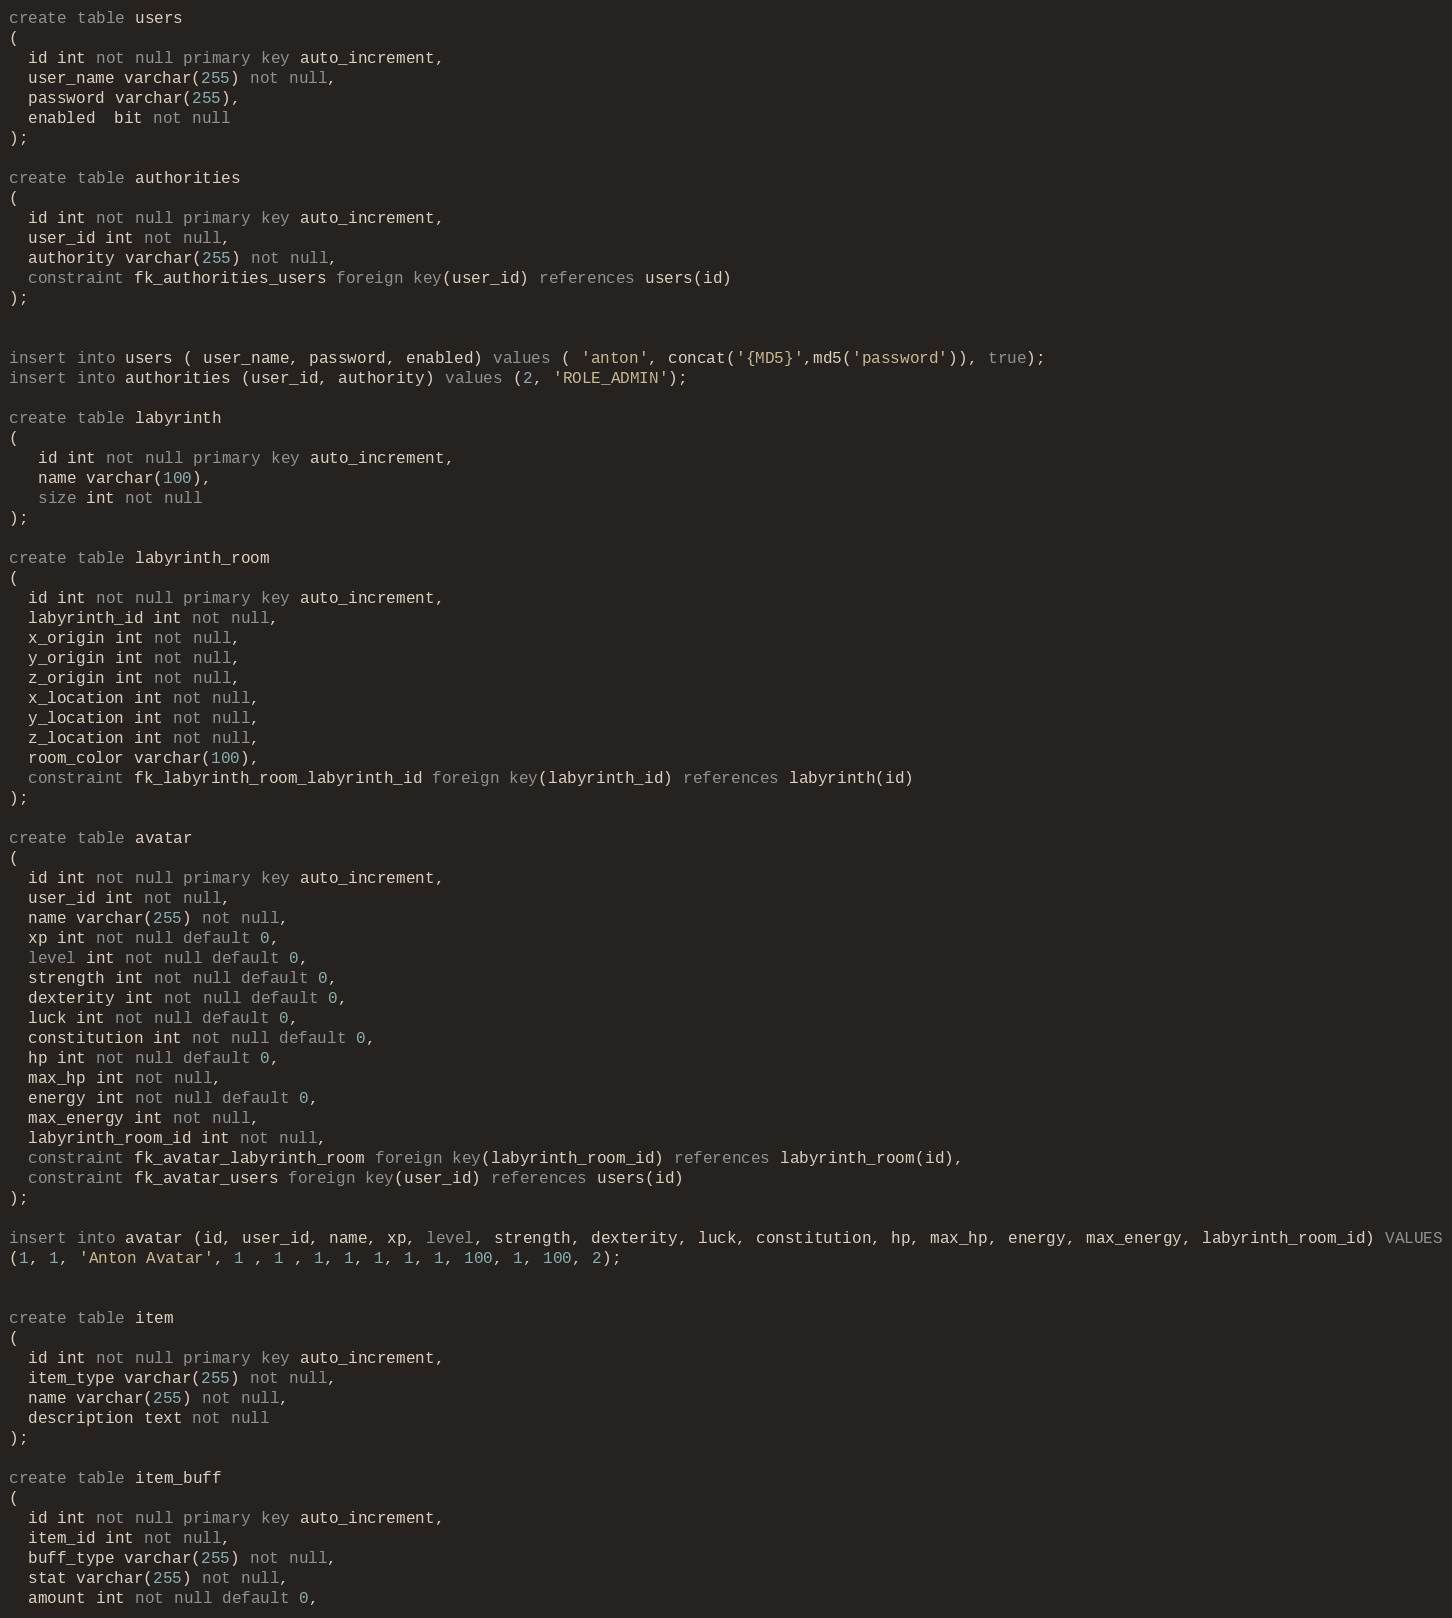Convert code to text. <code><loc_0><loc_0><loc_500><loc_500><_SQL_>create table users
(
  id int not null primary key auto_increment,
  user_name varchar(255) not null,
  password varchar(255),
  enabled  bit not null
);

create table authorities
(
  id int not null primary key auto_increment,
  user_id int not null,
  authority varchar(255) not null,
  constraint fk_authorities_users foreign key(user_id) references users(id)
);


insert into users ( user_name, password, enabled) values ( 'anton', concat('{MD5}',md5('password')), true);
insert into authorities (user_id, authority) values (2, 'ROLE_ADMIN');

create table labyrinth
(
   id int not null primary key auto_increment,
   name varchar(100),
   size int not null
);

create table labyrinth_room
(
  id int not null primary key auto_increment,
  labyrinth_id int not null,
  x_origin int not null,
  y_origin int not null,
  z_origin int not null,
  x_location int not null,
  y_location int not null,
  z_location int not null,
  room_color varchar(100),
  constraint fk_labyrinth_room_labyrinth_id foreign key(labyrinth_id) references labyrinth(id)
);

create table avatar
(
  id int not null primary key auto_increment,
  user_id int not null,
  name varchar(255) not null,
  xp int not null default 0,
  level int not null default 0,
  strength int not null default 0,
  dexterity int not null default 0,
  luck int not null default 0,
  constitution int not null default 0,
  hp int not null default 0,
  max_hp int not null,
  energy int not null default 0,
  max_energy int not null,
  labyrinth_room_id int not null,
  constraint fk_avatar_labyrinth_room foreign key(labyrinth_room_id) references labyrinth_room(id),
  constraint fk_avatar_users foreign key(user_id) references users(id)
);

insert into avatar (id, user_id, name, xp, level, strength, dexterity, luck, constitution, hp, max_hp, energy, max_energy, labyrinth_room_id) VALUES
(1, 1, 'Anton Avatar', 1 , 1 , 1, 1, 1, 1, 1, 100, 1, 100, 2);


create table item
(
  id int not null primary key auto_increment,
  item_type varchar(255) not null,
  name varchar(255) not null,
  description text not null
);

create table item_buff
(
  id int not null primary key auto_increment,
  item_id int not null,
  buff_type varchar(255) not null,
  stat varchar(255) not null,
  amount int not null default 0,</code> 